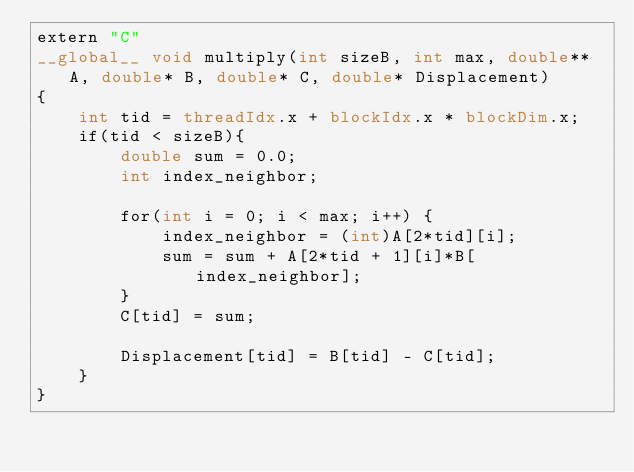Convert code to text. <code><loc_0><loc_0><loc_500><loc_500><_Cuda_>extern "C"
__global__ void multiply(int sizeB, int max, double** A, double* B, double* C, double* Displacement)
{
    int tid = threadIdx.x + blockIdx.x * blockDim.x;
    if(tid < sizeB){
        double sum = 0.0;
        int index_neighbor;
        
        for(int i = 0; i < max; i++) {
            index_neighbor = (int)A[2*tid][i];
            sum = sum + A[2*tid + 1][i]*B[index_neighbor];
        }
        C[tid] = sum;

        Displacement[tid] = B[tid] - C[tid];
    }
}</code> 